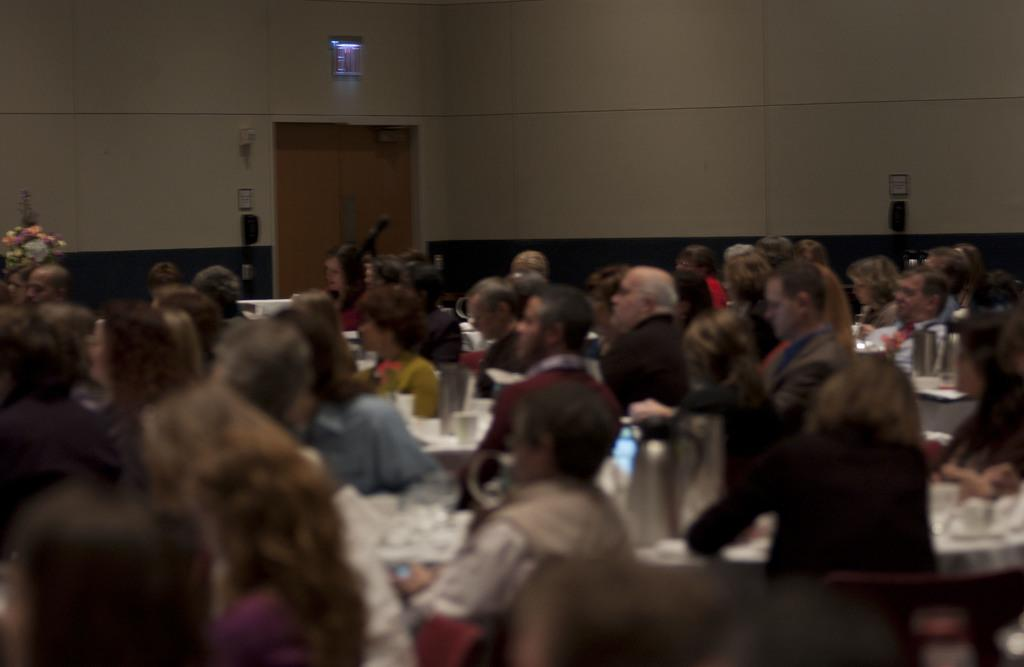What are the people in the image doing? The people in the image are seated on chairs. What objects are present in the image besides the people? There are tables and a flower vase in the image. What might be used for drinking in the image? There are glasses on the tables in the image. Can you see any hands reaching for the flower vase in the image? There is no mention of hands or anyone reaching for the flower vase in the image. 